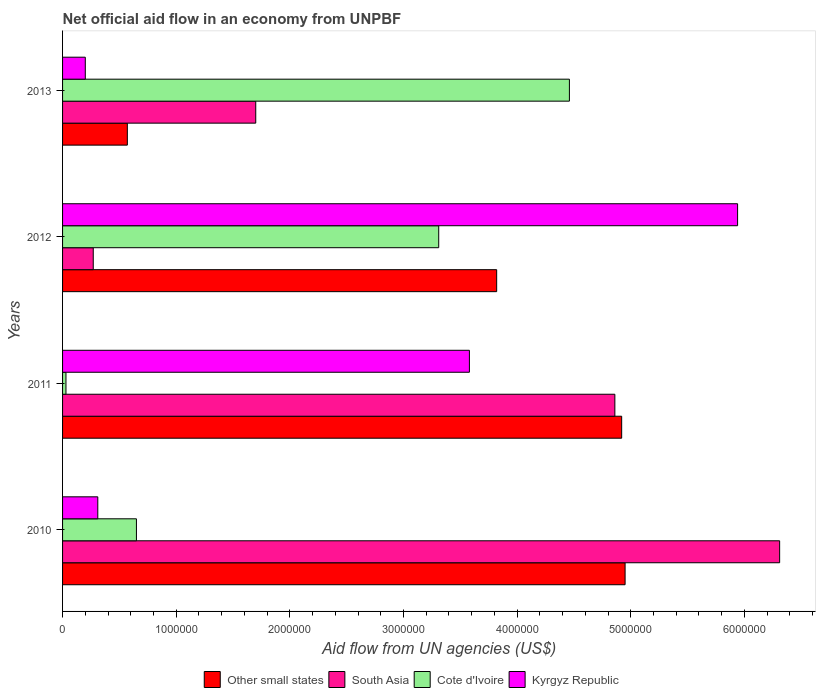How many groups of bars are there?
Your answer should be very brief. 4. Are the number of bars on each tick of the Y-axis equal?
Offer a very short reply. Yes. How many bars are there on the 3rd tick from the bottom?
Make the answer very short. 4. What is the label of the 3rd group of bars from the top?
Give a very brief answer. 2011. What is the net official aid flow in Other small states in 2011?
Ensure brevity in your answer.  4.92e+06. Across all years, what is the maximum net official aid flow in Cote d'Ivoire?
Provide a succinct answer. 4.46e+06. Across all years, what is the minimum net official aid flow in Cote d'Ivoire?
Your response must be concise. 3.00e+04. In which year was the net official aid flow in South Asia minimum?
Ensure brevity in your answer.  2012. What is the total net official aid flow in South Asia in the graph?
Offer a terse response. 1.31e+07. What is the difference between the net official aid flow in Kyrgyz Republic in 2012 and that in 2013?
Keep it short and to the point. 5.74e+06. What is the difference between the net official aid flow in South Asia in 2011 and the net official aid flow in Cote d'Ivoire in 2012?
Keep it short and to the point. 1.55e+06. What is the average net official aid flow in Other small states per year?
Your response must be concise. 3.56e+06. In the year 2011, what is the difference between the net official aid flow in Other small states and net official aid flow in Cote d'Ivoire?
Give a very brief answer. 4.89e+06. In how many years, is the net official aid flow in South Asia greater than 1000000 US$?
Your response must be concise. 3. What is the ratio of the net official aid flow in Kyrgyz Republic in 2010 to that in 2011?
Offer a terse response. 0.09. Is the difference between the net official aid flow in Other small states in 2010 and 2013 greater than the difference between the net official aid flow in Cote d'Ivoire in 2010 and 2013?
Make the answer very short. Yes. What is the difference between the highest and the second highest net official aid flow in Kyrgyz Republic?
Your response must be concise. 2.36e+06. What is the difference between the highest and the lowest net official aid flow in Other small states?
Provide a short and direct response. 4.38e+06. In how many years, is the net official aid flow in South Asia greater than the average net official aid flow in South Asia taken over all years?
Keep it short and to the point. 2. Is the sum of the net official aid flow in Cote d'Ivoire in 2010 and 2011 greater than the maximum net official aid flow in Other small states across all years?
Your answer should be compact. No. Is it the case that in every year, the sum of the net official aid flow in Other small states and net official aid flow in South Asia is greater than the sum of net official aid flow in Kyrgyz Republic and net official aid flow in Cote d'Ivoire?
Give a very brief answer. No. What does the 4th bar from the top in 2011 represents?
Your response must be concise. Other small states. What does the 3rd bar from the bottom in 2011 represents?
Provide a short and direct response. Cote d'Ivoire. How many bars are there?
Make the answer very short. 16. Are all the bars in the graph horizontal?
Keep it short and to the point. Yes. How many years are there in the graph?
Make the answer very short. 4. What is the difference between two consecutive major ticks on the X-axis?
Your response must be concise. 1.00e+06. Are the values on the major ticks of X-axis written in scientific E-notation?
Make the answer very short. No. Does the graph contain any zero values?
Provide a short and direct response. No. Does the graph contain grids?
Make the answer very short. No. Where does the legend appear in the graph?
Give a very brief answer. Bottom center. What is the title of the graph?
Your response must be concise. Net official aid flow in an economy from UNPBF. What is the label or title of the X-axis?
Offer a terse response. Aid flow from UN agencies (US$). What is the label or title of the Y-axis?
Your response must be concise. Years. What is the Aid flow from UN agencies (US$) of Other small states in 2010?
Ensure brevity in your answer.  4.95e+06. What is the Aid flow from UN agencies (US$) in South Asia in 2010?
Offer a terse response. 6.31e+06. What is the Aid flow from UN agencies (US$) of Cote d'Ivoire in 2010?
Your response must be concise. 6.50e+05. What is the Aid flow from UN agencies (US$) of Kyrgyz Republic in 2010?
Offer a very short reply. 3.10e+05. What is the Aid flow from UN agencies (US$) of Other small states in 2011?
Provide a short and direct response. 4.92e+06. What is the Aid flow from UN agencies (US$) in South Asia in 2011?
Provide a short and direct response. 4.86e+06. What is the Aid flow from UN agencies (US$) of Kyrgyz Republic in 2011?
Your response must be concise. 3.58e+06. What is the Aid flow from UN agencies (US$) of Other small states in 2012?
Make the answer very short. 3.82e+06. What is the Aid flow from UN agencies (US$) in South Asia in 2012?
Make the answer very short. 2.70e+05. What is the Aid flow from UN agencies (US$) of Cote d'Ivoire in 2012?
Keep it short and to the point. 3.31e+06. What is the Aid flow from UN agencies (US$) of Kyrgyz Republic in 2012?
Offer a very short reply. 5.94e+06. What is the Aid flow from UN agencies (US$) in Other small states in 2013?
Make the answer very short. 5.70e+05. What is the Aid flow from UN agencies (US$) of South Asia in 2013?
Your answer should be compact. 1.70e+06. What is the Aid flow from UN agencies (US$) in Cote d'Ivoire in 2013?
Your answer should be very brief. 4.46e+06. Across all years, what is the maximum Aid flow from UN agencies (US$) of Other small states?
Give a very brief answer. 4.95e+06. Across all years, what is the maximum Aid flow from UN agencies (US$) in South Asia?
Offer a terse response. 6.31e+06. Across all years, what is the maximum Aid flow from UN agencies (US$) in Cote d'Ivoire?
Give a very brief answer. 4.46e+06. Across all years, what is the maximum Aid flow from UN agencies (US$) of Kyrgyz Republic?
Your response must be concise. 5.94e+06. Across all years, what is the minimum Aid flow from UN agencies (US$) of Other small states?
Keep it short and to the point. 5.70e+05. Across all years, what is the minimum Aid flow from UN agencies (US$) in South Asia?
Provide a succinct answer. 2.70e+05. Across all years, what is the minimum Aid flow from UN agencies (US$) of Cote d'Ivoire?
Ensure brevity in your answer.  3.00e+04. Across all years, what is the minimum Aid flow from UN agencies (US$) of Kyrgyz Republic?
Keep it short and to the point. 2.00e+05. What is the total Aid flow from UN agencies (US$) of Other small states in the graph?
Offer a terse response. 1.43e+07. What is the total Aid flow from UN agencies (US$) in South Asia in the graph?
Your response must be concise. 1.31e+07. What is the total Aid flow from UN agencies (US$) in Cote d'Ivoire in the graph?
Ensure brevity in your answer.  8.45e+06. What is the total Aid flow from UN agencies (US$) in Kyrgyz Republic in the graph?
Provide a short and direct response. 1.00e+07. What is the difference between the Aid flow from UN agencies (US$) of Other small states in 2010 and that in 2011?
Your answer should be very brief. 3.00e+04. What is the difference between the Aid flow from UN agencies (US$) of South Asia in 2010 and that in 2011?
Ensure brevity in your answer.  1.45e+06. What is the difference between the Aid flow from UN agencies (US$) in Cote d'Ivoire in 2010 and that in 2011?
Your answer should be compact. 6.20e+05. What is the difference between the Aid flow from UN agencies (US$) in Kyrgyz Republic in 2010 and that in 2011?
Offer a very short reply. -3.27e+06. What is the difference between the Aid flow from UN agencies (US$) in Other small states in 2010 and that in 2012?
Offer a terse response. 1.13e+06. What is the difference between the Aid flow from UN agencies (US$) of South Asia in 2010 and that in 2012?
Your response must be concise. 6.04e+06. What is the difference between the Aid flow from UN agencies (US$) of Cote d'Ivoire in 2010 and that in 2012?
Your response must be concise. -2.66e+06. What is the difference between the Aid flow from UN agencies (US$) of Kyrgyz Republic in 2010 and that in 2012?
Ensure brevity in your answer.  -5.63e+06. What is the difference between the Aid flow from UN agencies (US$) of Other small states in 2010 and that in 2013?
Keep it short and to the point. 4.38e+06. What is the difference between the Aid flow from UN agencies (US$) of South Asia in 2010 and that in 2013?
Make the answer very short. 4.61e+06. What is the difference between the Aid flow from UN agencies (US$) of Cote d'Ivoire in 2010 and that in 2013?
Your response must be concise. -3.81e+06. What is the difference between the Aid flow from UN agencies (US$) of Kyrgyz Republic in 2010 and that in 2013?
Your response must be concise. 1.10e+05. What is the difference between the Aid flow from UN agencies (US$) of Other small states in 2011 and that in 2012?
Provide a succinct answer. 1.10e+06. What is the difference between the Aid flow from UN agencies (US$) of South Asia in 2011 and that in 2012?
Keep it short and to the point. 4.59e+06. What is the difference between the Aid flow from UN agencies (US$) of Cote d'Ivoire in 2011 and that in 2012?
Offer a terse response. -3.28e+06. What is the difference between the Aid flow from UN agencies (US$) of Kyrgyz Republic in 2011 and that in 2012?
Your response must be concise. -2.36e+06. What is the difference between the Aid flow from UN agencies (US$) of Other small states in 2011 and that in 2013?
Ensure brevity in your answer.  4.35e+06. What is the difference between the Aid flow from UN agencies (US$) of South Asia in 2011 and that in 2013?
Ensure brevity in your answer.  3.16e+06. What is the difference between the Aid flow from UN agencies (US$) of Cote d'Ivoire in 2011 and that in 2013?
Offer a terse response. -4.43e+06. What is the difference between the Aid flow from UN agencies (US$) in Kyrgyz Republic in 2011 and that in 2013?
Provide a succinct answer. 3.38e+06. What is the difference between the Aid flow from UN agencies (US$) of Other small states in 2012 and that in 2013?
Offer a very short reply. 3.25e+06. What is the difference between the Aid flow from UN agencies (US$) of South Asia in 2012 and that in 2013?
Ensure brevity in your answer.  -1.43e+06. What is the difference between the Aid flow from UN agencies (US$) in Cote d'Ivoire in 2012 and that in 2013?
Keep it short and to the point. -1.15e+06. What is the difference between the Aid flow from UN agencies (US$) in Kyrgyz Republic in 2012 and that in 2013?
Your response must be concise. 5.74e+06. What is the difference between the Aid flow from UN agencies (US$) in Other small states in 2010 and the Aid flow from UN agencies (US$) in South Asia in 2011?
Your answer should be very brief. 9.00e+04. What is the difference between the Aid flow from UN agencies (US$) in Other small states in 2010 and the Aid flow from UN agencies (US$) in Cote d'Ivoire in 2011?
Offer a terse response. 4.92e+06. What is the difference between the Aid flow from UN agencies (US$) in Other small states in 2010 and the Aid flow from UN agencies (US$) in Kyrgyz Republic in 2011?
Your response must be concise. 1.37e+06. What is the difference between the Aid flow from UN agencies (US$) of South Asia in 2010 and the Aid flow from UN agencies (US$) of Cote d'Ivoire in 2011?
Offer a very short reply. 6.28e+06. What is the difference between the Aid flow from UN agencies (US$) in South Asia in 2010 and the Aid flow from UN agencies (US$) in Kyrgyz Republic in 2011?
Make the answer very short. 2.73e+06. What is the difference between the Aid flow from UN agencies (US$) of Cote d'Ivoire in 2010 and the Aid flow from UN agencies (US$) of Kyrgyz Republic in 2011?
Make the answer very short. -2.93e+06. What is the difference between the Aid flow from UN agencies (US$) in Other small states in 2010 and the Aid flow from UN agencies (US$) in South Asia in 2012?
Keep it short and to the point. 4.68e+06. What is the difference between the Aid flow from UN agencies (US$) in Other small states in 2010 and the Aid flow from UN agencies (US$) in Cote d'Ivoire in 2012?
Provide a short and direct response. 1.64e+06. What is the difference between the Aid flow from UN agencies (US$) of Other small states in 2010 and the Aid flow from UN agencies (US$) of Kyrgyz Republic in 2012?
Offer a terse response. -9.90e+05. What is the difference between the Aid flow from UN agencies (US$) of South Asia in 2010 and the Aid flow from UN agencies (US$) of Cote d'Ivoire in 2012?
Ensure brevity in your answer.  3.00e+06. What is the difference between the Aid flow from UN agencies (US$) in South Asia in 2010 and the Aid flow from UN agencies (US$) in Kyrgyz Republic in 2012?
Your response must be concise. 3.70e+05. What is the difference between the Aid flow from UN agencies (US$) of Cote d'Ivoire in 2010 and the Aid flow from UN agencies (US$) of Kyrgyz Republic in 2012?
Provide a short and direct response. -5.29e+06. What is the difference between the Aid flow from UN agencies (US$) of Other small states in 2010 and the Aid flow from UN agencies (US$) of South Asia in 2013?
Ensure brevity in your answer.  3.25e+06. What is the difference between the Aid flow from UN agencies (US$) of Other small states in 2010 and the Aid flow from UN agencies (US$) of Kyrgyz Republic in 2013?
Your answer should be very brief. 4.75e+06. What is the difference between the Aid flow from UN agencies (US$) of South Asia in 2010 and the Aid flow from UN agencies (US$) of Cote d'Ivoire in 2013?
Your response must be concise. 1.85e+06. What is the difference between the Aid flow from UN agencies (US$) of South Asia in 2010 and the Aid flow from UN agencies (US$) of Kyrgyz Republic in 2013?
Offer a terse response. 6.11e+06. What is the difference between the Aid flow from UN agencies (US$) of Cote d'Ivoire in 2010 and the Aid flow from UN agencies (US$) of Kyrgyz Republic in 2013?
Keep it short and to the point. 4.50e+05. What is the difference between the Aid flow from UN agencies (US$) of Other small states in 2011 and the Aid flow from UN agencies (US$) of South Asia in 2012?
Your response must be concise. 4.65e+06. What is the difference between the Aid flow from UN agencies (US$) in Other small states in 2011 and the Aid flow from UN agencies (US$) in Cote d'Ivoire in 2012?
Offer a very short reply. 1.61e+06. What is the difference between the Aid flow from UN agencies (US$) in Other small states in 2011 and the Aid flow from UN agencies (US$) in Kyrgyz Republic in 2012?
Provide a succinct answer. -1.02e+06. What is the difference between the Aid flow from UN agencies (US$) of South Asia in 2011 and the Aid flow from UN agencies (US$) of Cote d'Ivoire in 2012?
Offer a very short reply. 1.55e+06. What is the difference between the Aid flow from UN agencies (US$) in South Asia in 2011 and the Aid flow from UN agencies (US$) in Kyrgyz Republic in 2012?
Ensure brevity in your answer.  -1.08e+06. What is the difference between the Aid flow from UN agencies (US$) in Cote d'Ivoire in 2011 and the Aid flow from UN agencies (US$) in Kyrgyz Republic in 2012?
Your response must be concise. -5.91e+06. What is the difference between the Aid flow from UN agencies (US$) in Other small states in 2011 and the Aid flow from UN agencies (US$) in South Asia in 2013?
Provide a succinct answer. 3.22e+06. What is the difference between the Aid flow from UN agencies (US$) in Other small states in 2011 and the Aid flow from UN agencies (US$) in Kyrgyz Republic in 2013?
Your answer should be very brief. 4.72e+06. What is the difference between the Aid flow from UN agencies (US$) of South Asia in 2011 and the Aid flow from UN agencies (US$) of Cote d'Ivoire in 2013?
Make the answer very short. 4.00e+05. What is the difference between the Aid flow from UN agencies (US$) of South Asia in 2011 and the Aid flow from UN agencies (US$) of Kyrgyz Republic in 2013?
Your answer should be compact. 4.66e+06. What is the difference between the Aid flow from UN agencies (US$) of Cote d'Ivoire in 2011 and the Aid flow from UN agencies (US$) of Kyrgyz Republic in 2013?
Your answer should be compact. -1.70e+05. What is the difference between the Aid flow from UN agencies (US$) in Other small states in 2012 and the Aid flow from UN agencies (US$) in South Asia in 2013?
Make the answer very short. 2.12e+06. What is the difference between the Aid flow from UN agencies (US$) in Other small states in 2012 and the Aid flow from UN agencies (US$) in Cote d'Ivoire in 2013?
Give a very brief answer. -6.40e+05. What is the difference between the Aid flow from UN agencies (US$) of Other small states in 2012 and the Aid flow from UN agencies (US$) of Kyrgyz Republic in 2013?
Your response must be concise. 3.62e+06. What is the difference between the Aid flow from UN agencies (US$) in South Asia in 2012 and the Aid flow from UN agencies (US$) in Cote d'Ivoire in 2013?
Offer a terse response. -4.19e+06. What is the difference between the Aid flow from UN agencies (US$) of Cote d'Ivoire in 2012 and the Aid flow from UN agencies (US$) of Kyrgyz Republic in 2013?
Ensure brevity in your answer.  3.11e+06. What is the average Aid flow from UN agencies (US$) of Other small states per year?
Your response must be concise. 3.56e+06. What is the average Aid flow from UN agencies (US$) of South Asia per year?
Provide a succinct answer. 3.28e+06. What is the average Aid flow from UN agencies (US$) of Cote d'Ivoire per year?
Offer a very short reply. 2.11e+06. What is the average Aid flow from UN agencies (US$) in Kyrgyz Republic per year?
Provide a succinct answer. 2.51e+06. In the year 2010, what is the difference between the Aid flow from UN agencies (US$) of Other small states and Aid flow from UN agencies (US$) of South Asia?
Make the answer very short. -1.36e+06. In the year 2010, what is the difference between the Aid flow from UN agencies (US$) of Other small states and Aid flow from UN agencies (US$) of Cote d'Ivoire?
Your response must be concise. 4.30e+06. In the year 2010, what is the difference between the Aid flow from UN agencies (US$) of Other small states and Aid flow from UN agencies (US$) of Kyrgyz Republic?
Provide a succinct answer. 4.64e+06. In the year 2010, what is the difference between the Aid flow from UN agencies (US$) of South Asia and Aid flow from UN agencies (US$) of Cote d'Ivoire?
Your response must be concise. 5.66e+06. In the year 2010, what is the difference between the Aid flow from UN agencies (US$) in South Asia and Aid flow from UN agencies (US$) in Kyrgyz Republic?
Your answer should be very brief. 6.00e+06. In the year 2011, what is the difference between the Aid flow from UN agencies (US$) in Other small states and Aid flow from UN agencies (US$) in South Asia?
Give a very brief answer. 6.00e+04. In the year 2011, what is the difference between the Aid flow from UN agencies (US$) in Other small states and Aid flow from UN agencies (US$) in Cote d'Ivoire?
Your answer should be compact. 4.89e+06. In the year 2011, what is the difference between the Aid flow from UN agencies (US$) in Other small states and Aid flow from UN agencies (US$) in Kyrgyz Republic?
Provide a short and direct response. 1.34e+06. In the year 2011, what is the difference between the Aid flow from UN agencies (US$) of South Asia and Aid flow from UN agencies (US$) of Cote d'Ivoire?
Keep it short and to the point. 4.83e+06. In the year 2011, what is the difference between the Aid flow from UN agencies (US$) of South Asia and Aid flow from UN agencies (US$) of Kyrgyz Republic?
Give a very brief answer. 1.28e+06. In the year 2011, what is the difference between the Aid flow from UN agencies (US$) in Cote d'Ivoire and Aid flow from UN agencies (US$) in Kyrgyz Republic?
Offer a terse response. -3.55e+06. In the year 2012, what is the difference between the Aid flow from UN agencies (US$) of Other small states and Aid flow from UN agencies (US$) of South Asia?
Your answer should be very brief. 3.55e+06. In the year 2012, what is the difference between the Aid flow from UN agencies (US$) of Other small states and Aid flow from UN agencies (US$) of Cote d'Ivoire?
Keep it short and to the point. 5.10e+05. In the year 2012, what is the difference between the Aid flow from UN agencies (US$) in Other small states and Aid flow from UN agencies (US$) in Kyrgyz Republic?
Your answer should be compact. -2.12e+06. In the year 2012, what is the difference between the Aid flow from UN agencies (US$) of South Asia and Aid flow from UN agencies (US$) of Cote d'Ivoire?
Provide a succinct answer. -3.04e+06. In the year 2012, what is the difference between the Aid flow from UN agencies (US$) of South Asia and Aid flow from UN agencies (US$) of Kyrgyz Republic?
Provide a succinct answer. -5.67e+06. In the year 2012, what is the difference between the Aid flow from UN agencies (US$) of Cote d'Ivoire and Aid flow from UN agencies (US$) of Kyrgyz Republic?
Offer a terse response. -2.63e+06. In the year 2013, what is the difference between the Aid flow from UN agencies (US$) in Other small states and Aid flow from UN agencies (US$) in South Asia?
Give a very brief answer. -1.13e+06. In the year 2013, what is the difference between the Aid flow from UN agencies (US$) in Other small states and Aid flow from UN agencies (US$) in Cote d'Ivoire?
Give a very brief answer. -3.89e+06. In the year 2013, what is the difference between the Aid flow from UN agencies (US$) in South Asia and Aid flow from UN agencies (US$) in Cote d'Ivoire?
Your response must be concise. -2.76e+06. In the year 2013, what is the difference between the Aid flow from UN agencies (US$) of South Asia and Aid flow from UN agencies (US$) of Kyrgyz Republic?
Offer a terse response. 1.50e+06. In the year 2013, what is the difference between the Aid flow from UN agencies (US$) of Cote d'Ivoire and Aid flow from UN agencies (US$) of Kyrgyz Republic?
Provide a short and direct response. 4.26e+06. What is the ratio of the Aid flow from UN agencies (US$) in Other small states in 2010 to that in 2011?
Your response must be concise. 1.01. What is the ratio of the Aid flow from UN agencies (US$) in South Asia in 2010 to that in 2011?
Ensure brevity in your answer.  1.3. What is the ratio of the Aid flow from UN agencies (US$) in Cote d'Ivoire in 2010 to that in 2011?
Your answer should be very brief. 21.67. What is the ratio of the Aid flow from UN agencies (US$) in Kyrgyz Republic in 2010 to that in 2011?
Provide a short and direct response. 0.09. What is the ratio of the Aid flow from UN agencies (US$) in Other small states in 2010 to that in 2012?
Your answer should be compact. 1.3. What is the ratio of the Aid flow from UN agencies (US$) in South Asia in 2010 to that in 2012?
Your answer should be compact. 23.37. What is the ratio of the Aid flow from UN agencies (US$) of Cote d'Ivoire in 2010 to that in 2012?
Your answer should be very brief. 0.2. What is the ratio of the Aid flow from UN agencies (US$) in Kyrgyz Republic in 2010 to that in 2012?
Give a very brief answer. 0.05. What is the ratio of the Aid flow from UN agencies (US$) in Other small states in 2010 to that in 2013?
Your response must be concise. 8.68. What is the ratio of the Aid flow from UN agencies (US$) of South Asia in 2010 to that in 2013?
Your answer should be very brief. 3.71. What is the ratio of the Aid flow from UN agencies (US$) of Cote d'Ivoire in 2010 to that in 2013?
Keep it short and to the point. 0.15. What is the ratio of the Aid flow from UN agencies (US$) in Kyrgyz Republic in 2010 to that in 2013?
Your answer should be compact. 1.55. What is the ratio of the Aid flow from UN agencies (US$) of Other small states in 2011 to that in 2012?
Provide a succinct answer. 1.29. What is the ratio of the Aid flow from UN agencies (US$) in Cote d'Ivoire in 2011 to that in 2012?
Offer a very short reply. 0.01. What is the ratio of the Aid flow from UN agencies (US$) in Kyrgyz Republic in 2011 to that in 2012?
Give a very brief answer. 0.6. What is the ratio of the Aid flow from UN agencies (US$) in Other small states in 2011 to that in 2013?
Offer a very short reply. 8.63. What is the ratio of the Aid flow from UN agencies (US$) in South Asia in 2011 to that in 2013?
Offer a very short reply. 2.86. What is the ratio of the Aid flow from UN agencies (US$) of Cote d'Ivoire in 2011 to that in 2013?
Offer a very short reply. 0.01. What is the ratio of the Aid flow from UN agencies (US$) in Other small states in 2012 to that in 2013?
Ensure brevity in your answer.  6.7. What is the ratio of the Aid flow from UN agencies (US$) of South Asia in 2012 to that in 2013?
Offer a terse response. 0.16. What is the ratio of the Aid flow from UN agencies (US$) in Cote d'Ivoire in 2012 to that in 2013?
Your answer should be compact. 0.74. What is the ratio of the Aid flow from UN agencies (US$) in Kyrgyz Republic in 2012 to that in 2013?
Provide a succinct answer. 29.7. What is the difference between the highest and the second highest Aid flow from UN agencies (US$) of South Asia?
Give a very brief answer. 1.45e+06. What is the difference between the highest and the second highest Aid flow from UN agencies (US$) in Cote d'Ivoire?
Keep it short and to the point. 1.15e+06. What is the difference between the highest and the second highest Aid flow from UN agencies (US$) of Kyrgyz Republic?
Provide a succinct answer. 2.36e+06. What is the difference between the highest and the lowest Aid flow from UN agencies (US$) of Other small states?
Make the answer very short. 4.38e+06. What is the difference between the highest and the lowest Aid flow from UN agencies (US$) of South Asia?
Offer a very short reply. 6.04e+06. What is the difference between the highest and the lowest Aid flow from UN agencies (US$) in Cote d'Ivoire?
Give a very brief answer. 4.43e+06. What is the difference between the highest and the lowest Aid flow from UN agencies (US$) of Kyrgyz Republic?
Offer a very short reply. 5.74e+06. 